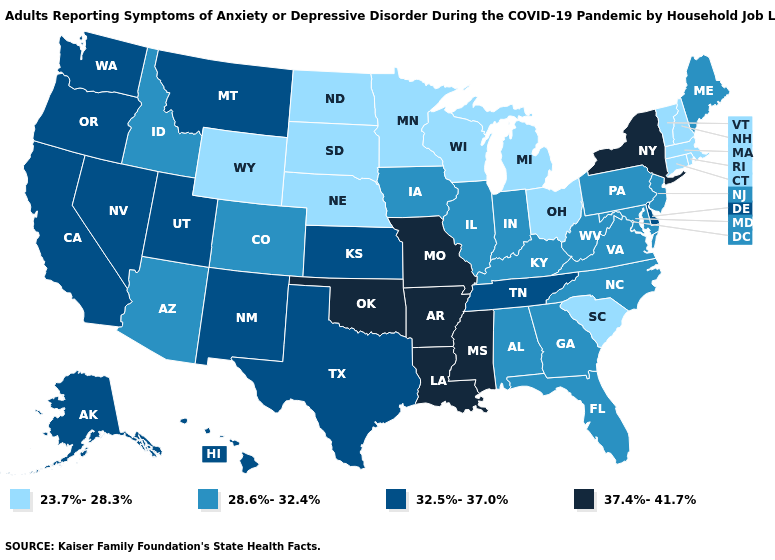What is the value of Georgia?
Short answer required. 28.6%-32.4%. What is the lowest value in the West?
Give a very brief answer. 23.7%-28.3%. Which states hav the highest value in the West?
Keep it brief. Alaska, California, Hawaii, Montana, Nevada, New Mexico, Oregon, Utah, Washington. What is the value of Connecticut?
Concise answer only. 23.7%-28.3%. Which states have the lowest value in the South?
Give a very brief answer. South Carolina. Among the states that border Mississippi , does Alabama have the lowest value?
Write a very short answer. Yes. Does the first symbol in the legend represent the smallest category?
Keep it brief. Yes. Does Illinois have the same value as Oregon?
Keep it brief. No. What is the highest value in states that border Wisconsin?
Answer briefly. 28.6%-32.4%. What is the value of Connecticut?
Answer briefly. 23.7%-28.3%. Does New York have the same value as Kentucky?
Be succinct. No. What is the value of Montana?
Short answer required. 32.5%-37.0%. Does Ohio have a higher value than Wisconsin?
Short answer required. No. Name the states that have a value in the range 23.7%-28.3%?
Give a very brief answer. Connecticut, Massachusetts, Michigan, Minnesota, Nebraska, New Hampshire, North Dakota, Ohio, Rhode Island, South Carolina, South Dakota, Vermont, Wisconsin, Wyoming. Does Hawaii have the same value as Ohio?
Answer briefly. No. 